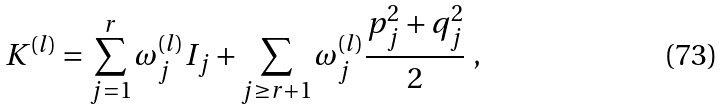<formula> <loc_0><loc_0><loc_500><loc_500>K ^ { ( l ) } = \sum _ { j = 1 } ^ { r } \omega _ { j } ^ { ( l ) } I _ { j } + \sum _ { j \geq r + 1 } \omega _ { j } ^ { ( l ) } \frac { p _ { j } ^ { 2 } + q _ { j } ^ { 2 } } { 2 } \ ,</formula> 